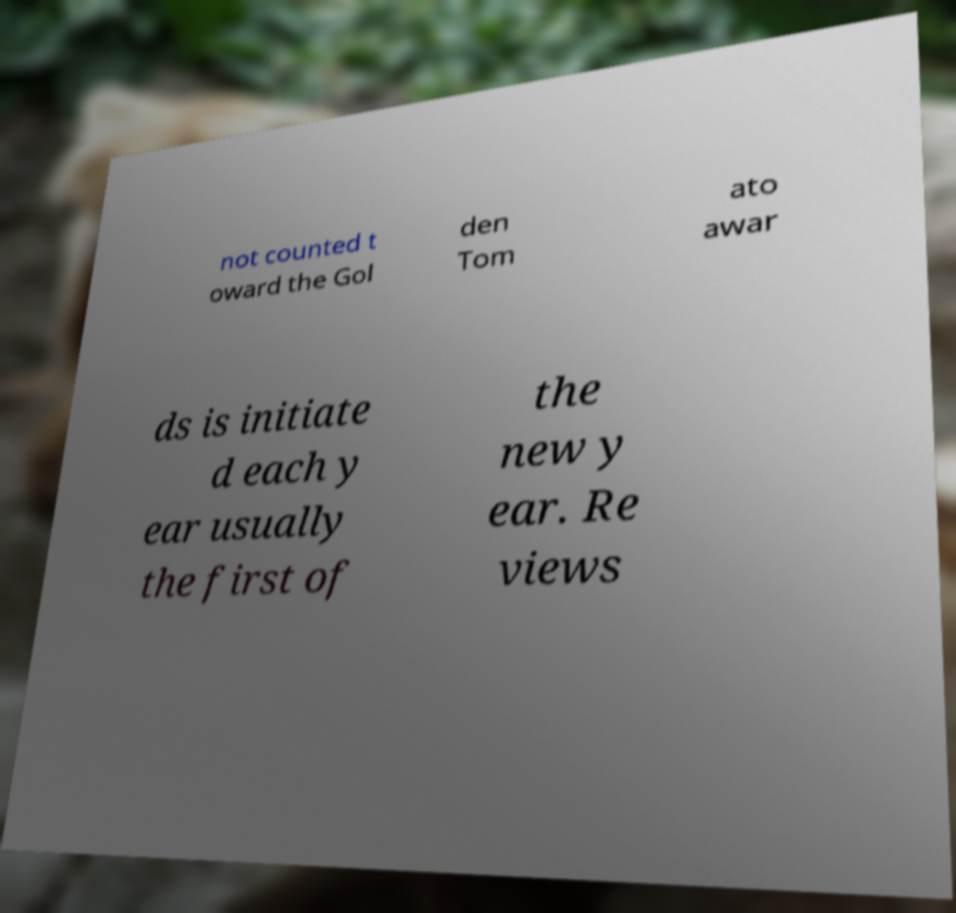I need the written content from this picture converted into text. Can you do that? not counted t oward the Gol den Tom ato awar ds is initiate d each y ear usually the first of the new y ear. Re views 